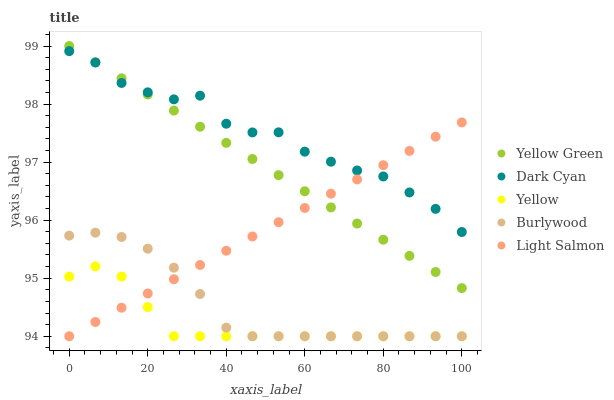Does Yellow have the minimum area under the curve?
Answer yes or no. Yes. Does Dark Cyan have the maximum area under the curve?
Answer yes or no. Yes. Does Burlywood have the minimum area under the curve?
Answer yes or no. No. Does Burlywood have the maximum area under the curve?
Answer yes or no. No. Is Light Salmon the smoothest?
Answer yes or no. Yes. Is Dark Cyan the roughest?
Answer yes or no. Yes. Is Burlywood the smoothest?
Answer yes or no. No. Is Burlywood the roughest?
Answer yes or no. No. Does Burlywood have the lowest value?
Answer yes or no. Yes. Does Yellow Green have the lowest value?
Answer yes or no. No. Does Yellow Green have the highest value?
Answer yes or no. Yes. Does Burlywood have the highest value?
Answer yes or no. No. Is Yellow less than Dark Cyan?
Answer yes or no. Yes. Is Dark Cyan greater than Yellow?
Answer yes or no. Yes. Does Burlywood intersect Light Salmon?
Answer yes or no. Yes. Is Burlywood less than Light Salmon?
Answer yes or no. No. Is Burlywood greater than Light Salmon?
Answer yes or no. No. Does Yellow intersect Dark Cyan?
Answer yes or no. No. 